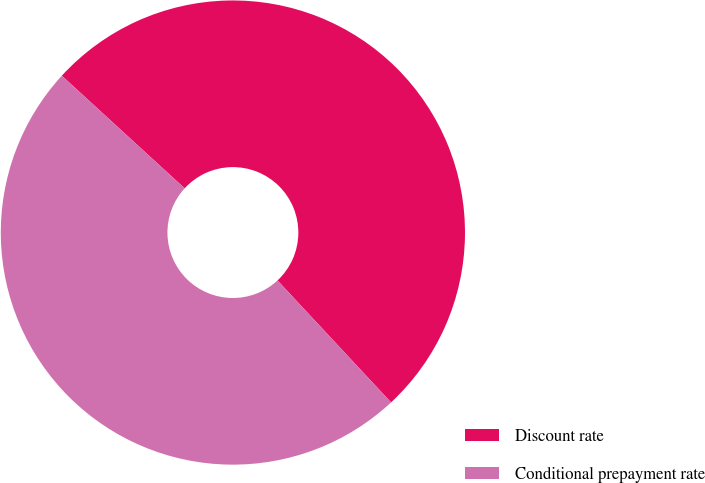Convert chart to OTSL. <chart><loc_0><loc_0><loc_500><loc_500><pie_chart><fcel>Discount rate<fcel>Conditional prepayment rate<nl><fcel>51.26%<fcel>48.74%<nl></chart> 